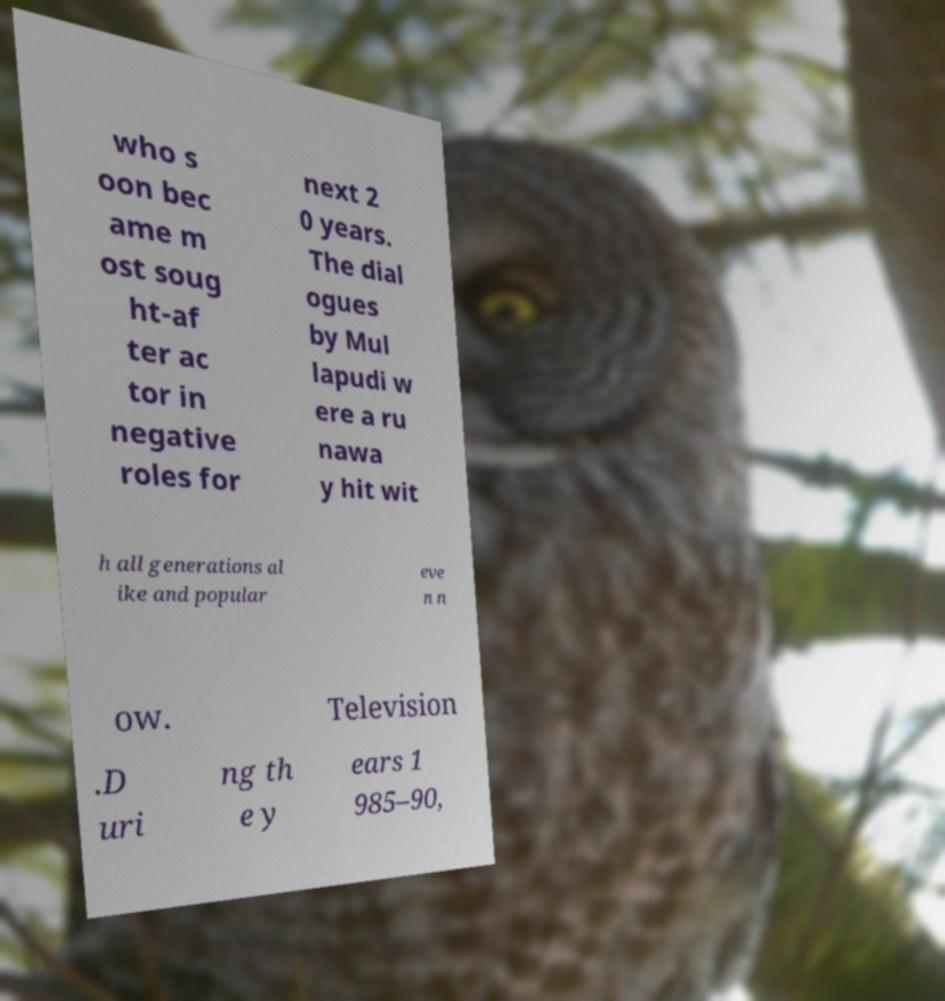Please read and relay the text visible in this image. What does it say? who s oon bec ame m ost soug ht-af ter ac tor in negative roles for next 2 0 years. The dial ogues by Mul lapudi w ere a ru nawa y hit wit h all generations al ike and popular eve n n ow. Television .D uri ng th e y ears 1 985–90, 